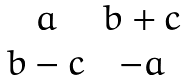<formula> <loc_0><loc_0><loc_500><loc_500>\begin{array} { c c } { a } & { b + c } \\ { b - c } & { - a } \end{array}</formula> 